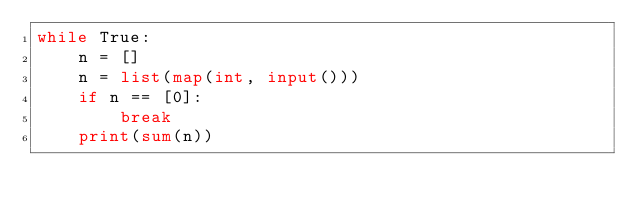Convert code to text. <code><loc_0><loc_0><loc_500><loc_500><_Python_>while True:
    n = []
    n = list(map(int, input()))
    if n == [0]:
        break
    print(sum(n))</code> 